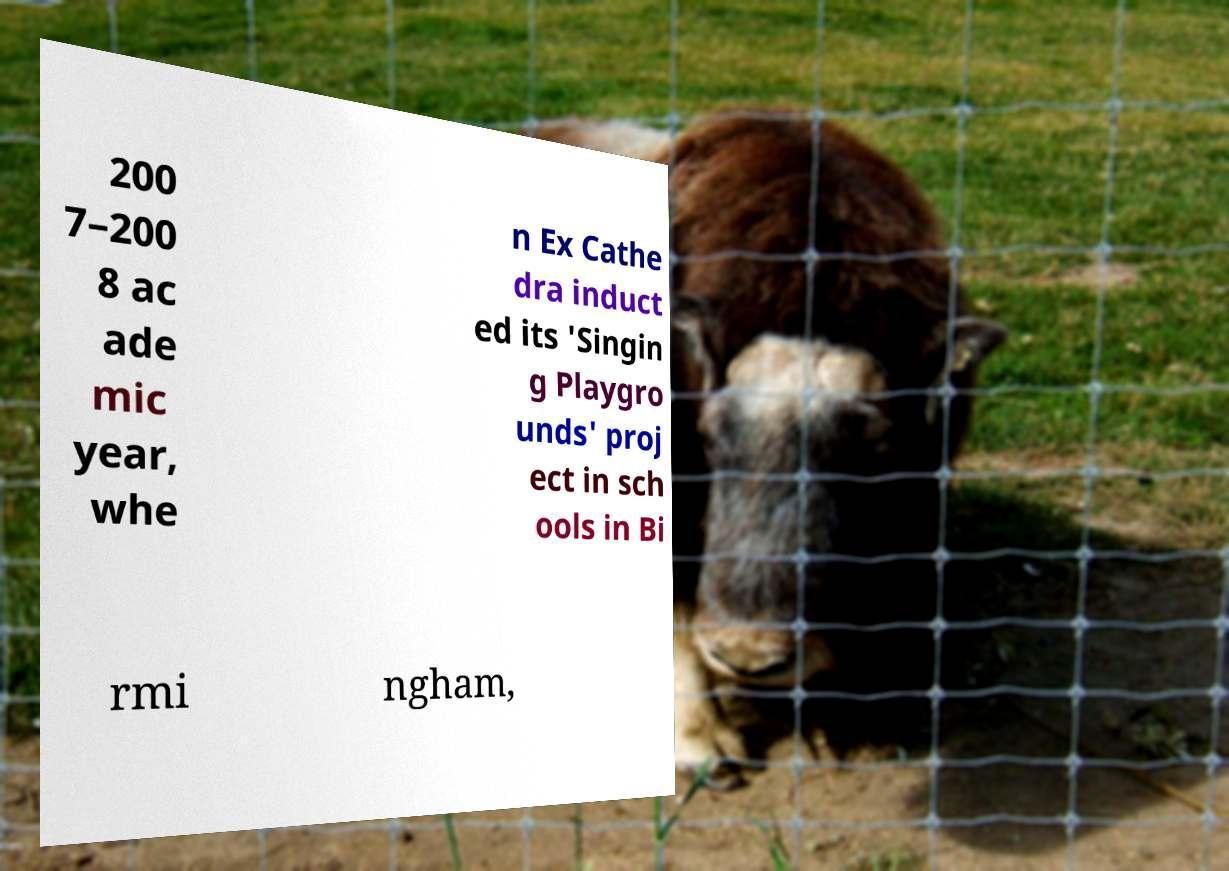Could you assist in decoding the text presented in this image and type it out clearly? 200 7–200 8 ac ade mic year, whe n Ex Cathe dra induct ed its 'Singin g Playgro unds' proj ect in sch ools in Bi rmi ngham, 